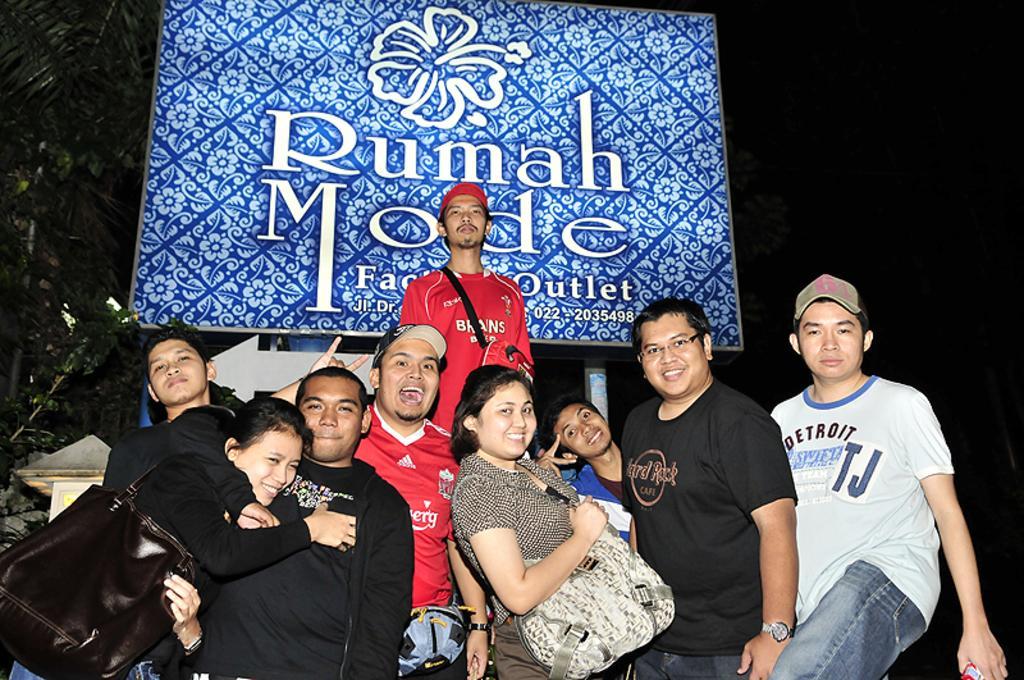In one or two sentences, can you explain what this image depicts? In this image I can see there are few persons and they are smiling and standing in front of the board ,on the board I can see text and colorful designs 